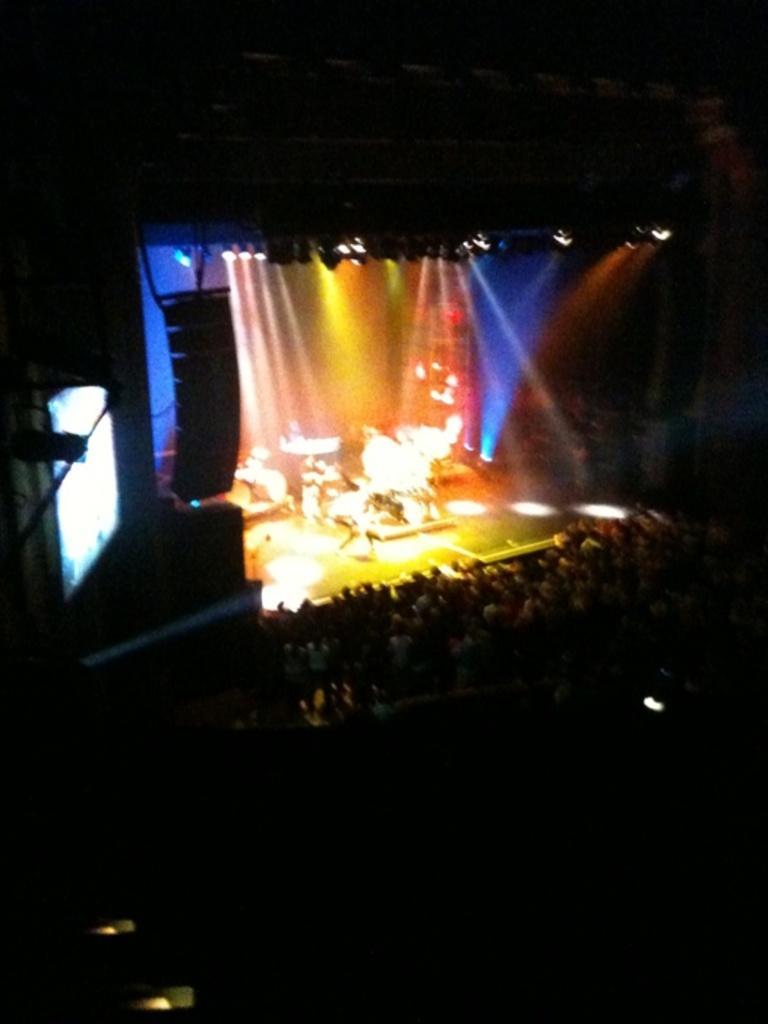In one or two sentences, can you explain what this image depicts? This image is taken from top angle. At the center of the image there is a stage with some instruments, in front of the stage there are some audience and the background is dark. 